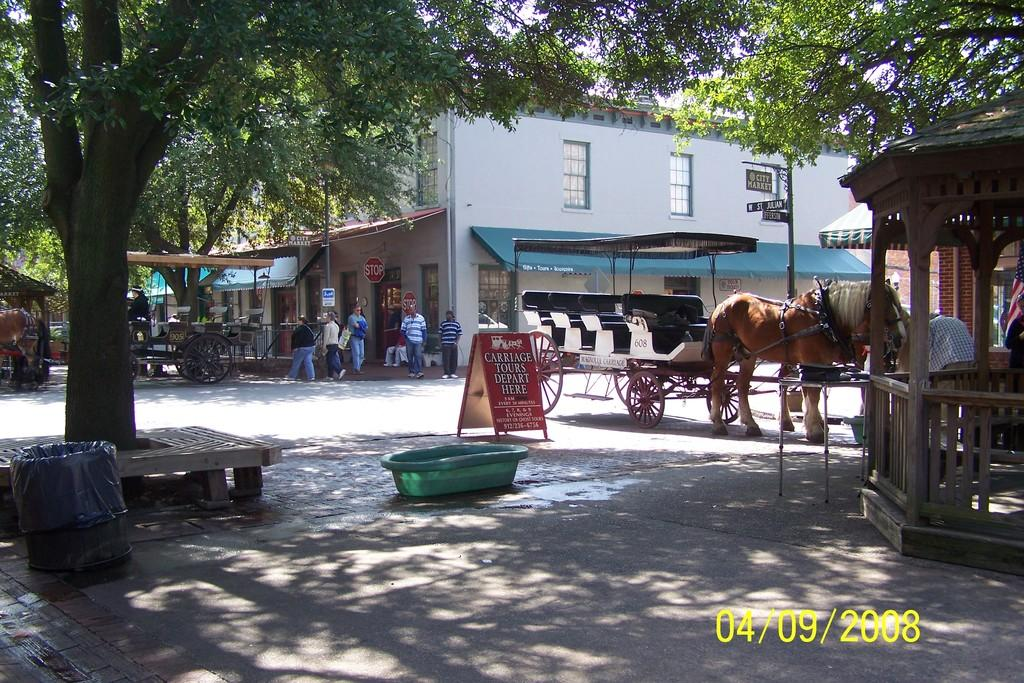What type of pathway is visible in the image? There is a road in the image. What type of natural elements can be seen in the image? There are trees in the image. What type of man-made structures are present in the image? There are buildings in the image. What type of signage is visible in the image? There are boards in the image. What type of container is present in the image? There is a basket in the image. What type of transportation is visible in the image? There are carts in the image. What type of animal is present in the image? There is a horse in the image. What type of vertical structure is present in the image? There is a pole in the image. What part of the natural environment is visible in the image? The sky is visible in the image. What type of creature is having breakfast in the image? There is no creature having breakfast in the image. How does the horse move around in the image? The horse does not move around in the image; it is stationary. 